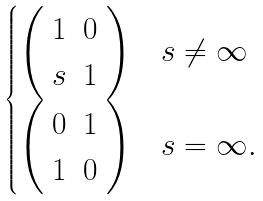Convert formula to latex. <formula><loc_0><loc_0><loc_500><loc_500>\begin{cases} \left ( \begin{array} { c c } 1 & 0 \\ s & 1 \end{array} \right ) & s \ne \infty \\ \left ( \begin{array} { c c } 0 & 1 \\ 1 & 0 \end{array} \right ) & s = \infty . \end{cases}</formula> 